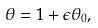Convert formula to latex. <formula><loc_0><loc_0><loc_500><loc_500>\theta = 1 + \epsilon \theta _ { 0 } ,</formula> 